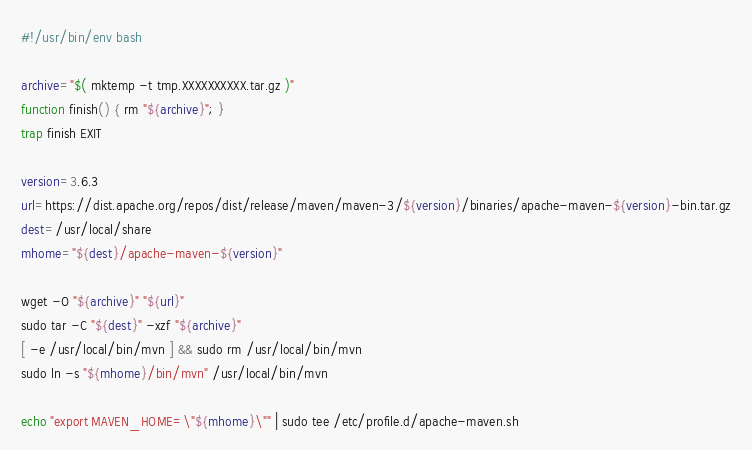<code> <loc_0><loc_0><loc_500><loc_500><_Bash_>#!/usr/bin/env bash

archive="$( mktemp -t tmp.XXXXXXXXXX.tar.gz )"
function finish() { rm "${archive}"; }
trap finish EXIT

version=3.6.3
url=https://dist.apache.org/repos/dist/release/maven/maven-3/${version}/binaries/apache-maven-${version}-bin.tar.gz
dest=/usr/local/share
mhome="${dest}/apache-maven-${version}"

wget -O "${archive}" "${url}"
sudo tar -C "${dest}" -xzf "${archive}"
[ -e /usr/local/bin/mvn ] && sudo rm /usr/local/bin/mvn
sudo ln -s "${mhome}/bin/mvn" /usr/local/bin/mvn

echo "export MAVEN_HOME=\"${mhome}\"" | sudo tee /etc/profile.d/apache-maven.sh
</code> 